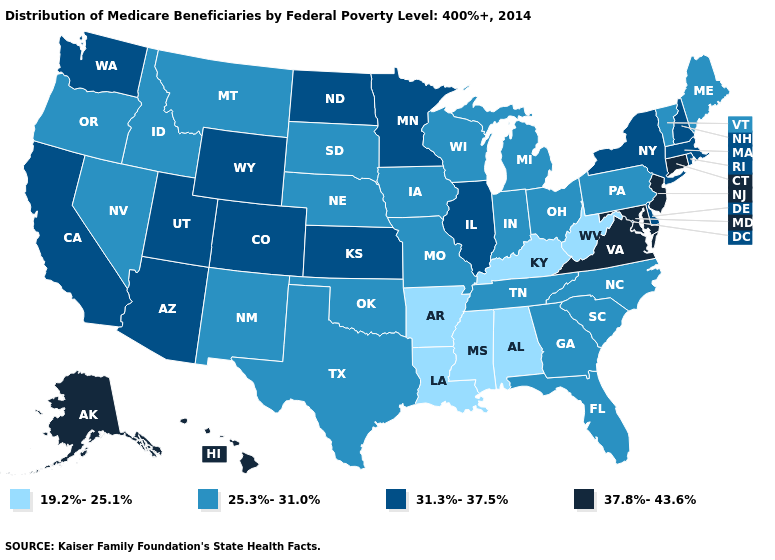Does Michigan have the highest value in the USA?
Keep it brief. No. What is the highest value in the South ?
Be succinct. 37.8%-43.6%. Does Washington have a lower value than Maryland?
Quick response, please. Yes. Does the map have missing data?
Answer briefly. No. What is the lowest value in the MidWest?
Be succinct. 25.3%-31.0%. What is the value of Virginia?
Keep it brief. 37.8%-43.6%. Does Kansas have the highest value in the MidWest?
Concise answer only. Yes. What is the lowest value in the South?
Write a very short answer. 19.2%-25.1%. Among the states that border Massachusetts , which have the highest value?
Keep it brief. Connecticut. Among the states that border Indiana , does Illinois have the highest value?
Answer briefly. Yes. What is the lowest value in the USA?
Answer briefly. 19.2%-25.1%. Name the states that have a value in the range 31.3%-37.5%?
Short answer required. Arizona, California, Colorado, Delaware, Illinois, Kansas, Massachusetts, Minnesota, New Hampshire, New York, North Dakota, Rhode Island, Utah, Washington, Wyoming. What is the value of Kansas?
Short answer required. 31.3%-37.5%. What is the highest value in states that border Maine?
Be succinct. 31.3%-37.5%. What is the value of Pennsylvania?
Concise answer only. 25.3%-31.0%. 